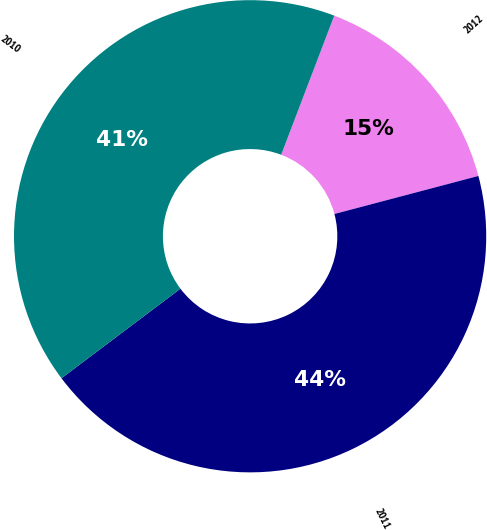<chart> <loc_0><loc_0><loc_500><loc_500><pie_chart><fcel>2012<fcel>2011<fcel>2010<nl><fcel>15.09%<fcel>43.84%<fcel>41.07%<nl></chart> 